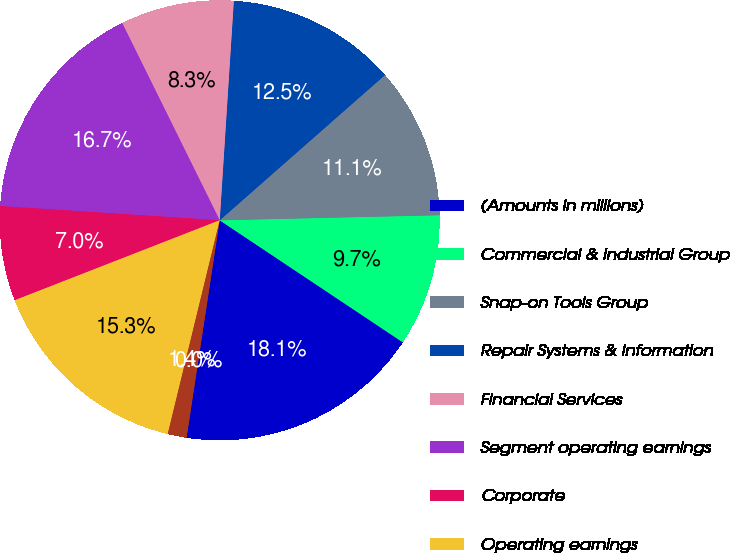Convert chart. <chart><loc_0><loc_0><loc_500><loc_500><pie_chart><fcel>(Amounts in millions)<fcel>Commercial & Industrial Group<fcel>Snap-on Tools Group<fcel>Repair Systems & Information<fcel>Financial Services<fcel>Segment operating earnings<fcel>Corporate<fcel>Operating earnings<fcel>Interest expense<fcel>Other income (expense) - net<nl><fcel>18.05%<fcel>9.72%<fcel>11.11%<fcel>12.5%<fcel>8.33%<fcel>16.66%<fcel>6.95%<fcel>15.28%<fcel>1.39%<fcel>0.0%<nl></chart> 